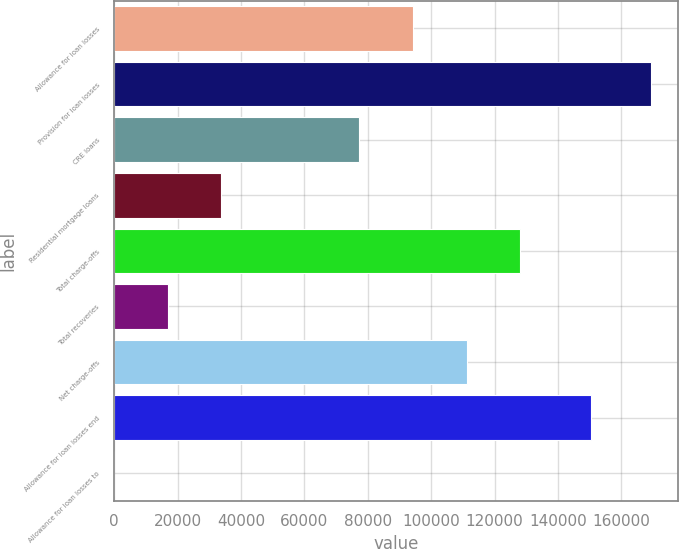Convert chart to OTSL. <chart><loc_0><loc_0><loc_500><loc_500><bar_chart><fcel>Allowance for loan losses<fcel>Provision for loan losses<fcel>CRE loans<fcel>Residential mortgage loans<fcel>Total charge-offs<fcel>Total recoveries<fcel>Net charge-offs<fcel>Allowance for loan losses end<fcel>Allowance for loan losses to<nl><fcel>94250.9<fcel>169341<fcel>77317<fcel>33870<fcel>128119<fcel>16936.1<fcel>111185<fcel>150272<fcel>2.23<nl></chart> 